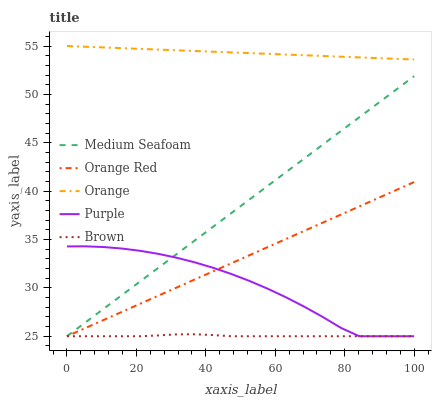Does Brown have the minimum area under the curve?
Answer yes or no. Yes. Does Orange have the maximum area under the curve?
Answer yes or no. Yes. Does Purple have the minimum area under the curve?
Answer yes or no. No. Does Purple have the maximum area under the curve?
Answer yes or no. No. Is Orange Red the smoothest?
Answer yes or no. Yes. Is Purple the roughest?
Answer yes or no. Yes. Is Medium Seafoam the smoothest?
Answer yes or no. No. Is Medium Seafoam the roughest?
Answer yes or no. No. Does Purple have the lowest value?
Answer yes or no. Yes. Does Orange have the highest value?
Answer yes or no. Yes. Does Purple have the highest value?
Answer yes or no. No. Is Purple less than Orange?
Answer yes or no. Yes. Is Orange greater than Orange Red?
Answer yes or no. Yes. Does Purple intersect Orange Red?
Answer yes or no. Yes. Is Purple less than Orange Red?
Answer yes or no. No. Is Purple greater than Orange Red?
Answer yes or no. No. Does Purple intersect Orange?
Answer yes or no. No. 